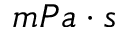<formula> <loc_0><loc_0><loc_500><loc_500>m P a \cdot s</formula> 